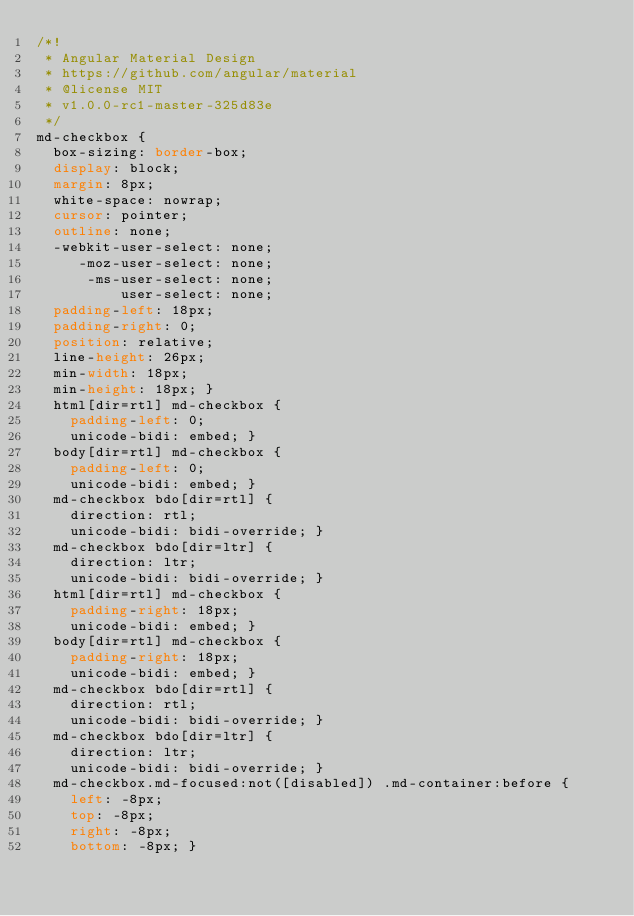Convert code to text. <code><loc_0><loc_0><loc_500><loc_500><_CSS_>/*!
 * Angular Material Design
 * https://github.com/angular/material
 * @license MIT
 * v1.0.0-rc1-master-325d83e
 */
md-checkbox {
  box-sizing: border-box;
  display: block;
  margin: 8px;
  white-space: nowrap;
  cursor: pointer;
  outline: none;
  -webkit-user-select: none;
     -moz-user-select: none;
      -ms-user-select: none;
          user-select: none;
  padding-left: 18px;
  padding-right: 0;
  position: relative;
  line-height: 26px;
  min-width: 18px;
  min-height: 18px; }
  html[dir=rtl] md-checkbox {
    padding-left: 0;
    unicode-bidi: embed; }
  body[dir=rtl] md-checkbox {
    padding-left: 0;
    unicode-bidi: embed; }
  md-checkbox bdo[dir=rtl] {
    direction: rtl;
    unicode-bidi: bidi-override; }
  md-checkbox bdo[dir=ltr] {
    direction: ltr;
    unicode-bidi: bidi-override; }
  html[dir=rtl] md-checkbox {
    padding-right: 18px;
    unicode-bidi: embed; }
  body[dir=rtl] md-checkbox {
    padding-right: 18px;
    unicode-bidi: embed; }
  md-checkbox bdo[dir=rtl] {
    direction: rtl;
    unicode-bidi: bidi-override; }
  md-checkbox bdo[dir=ltr] {
    direction: ltr;
    unicode-bidi: bidi-override; }
  md-checkbox.md-focused:not([disabled]) .md-container:before {
    left: -8px;
    top: -8px;
    right: -8px;
    bottom: -8px; }</code> 